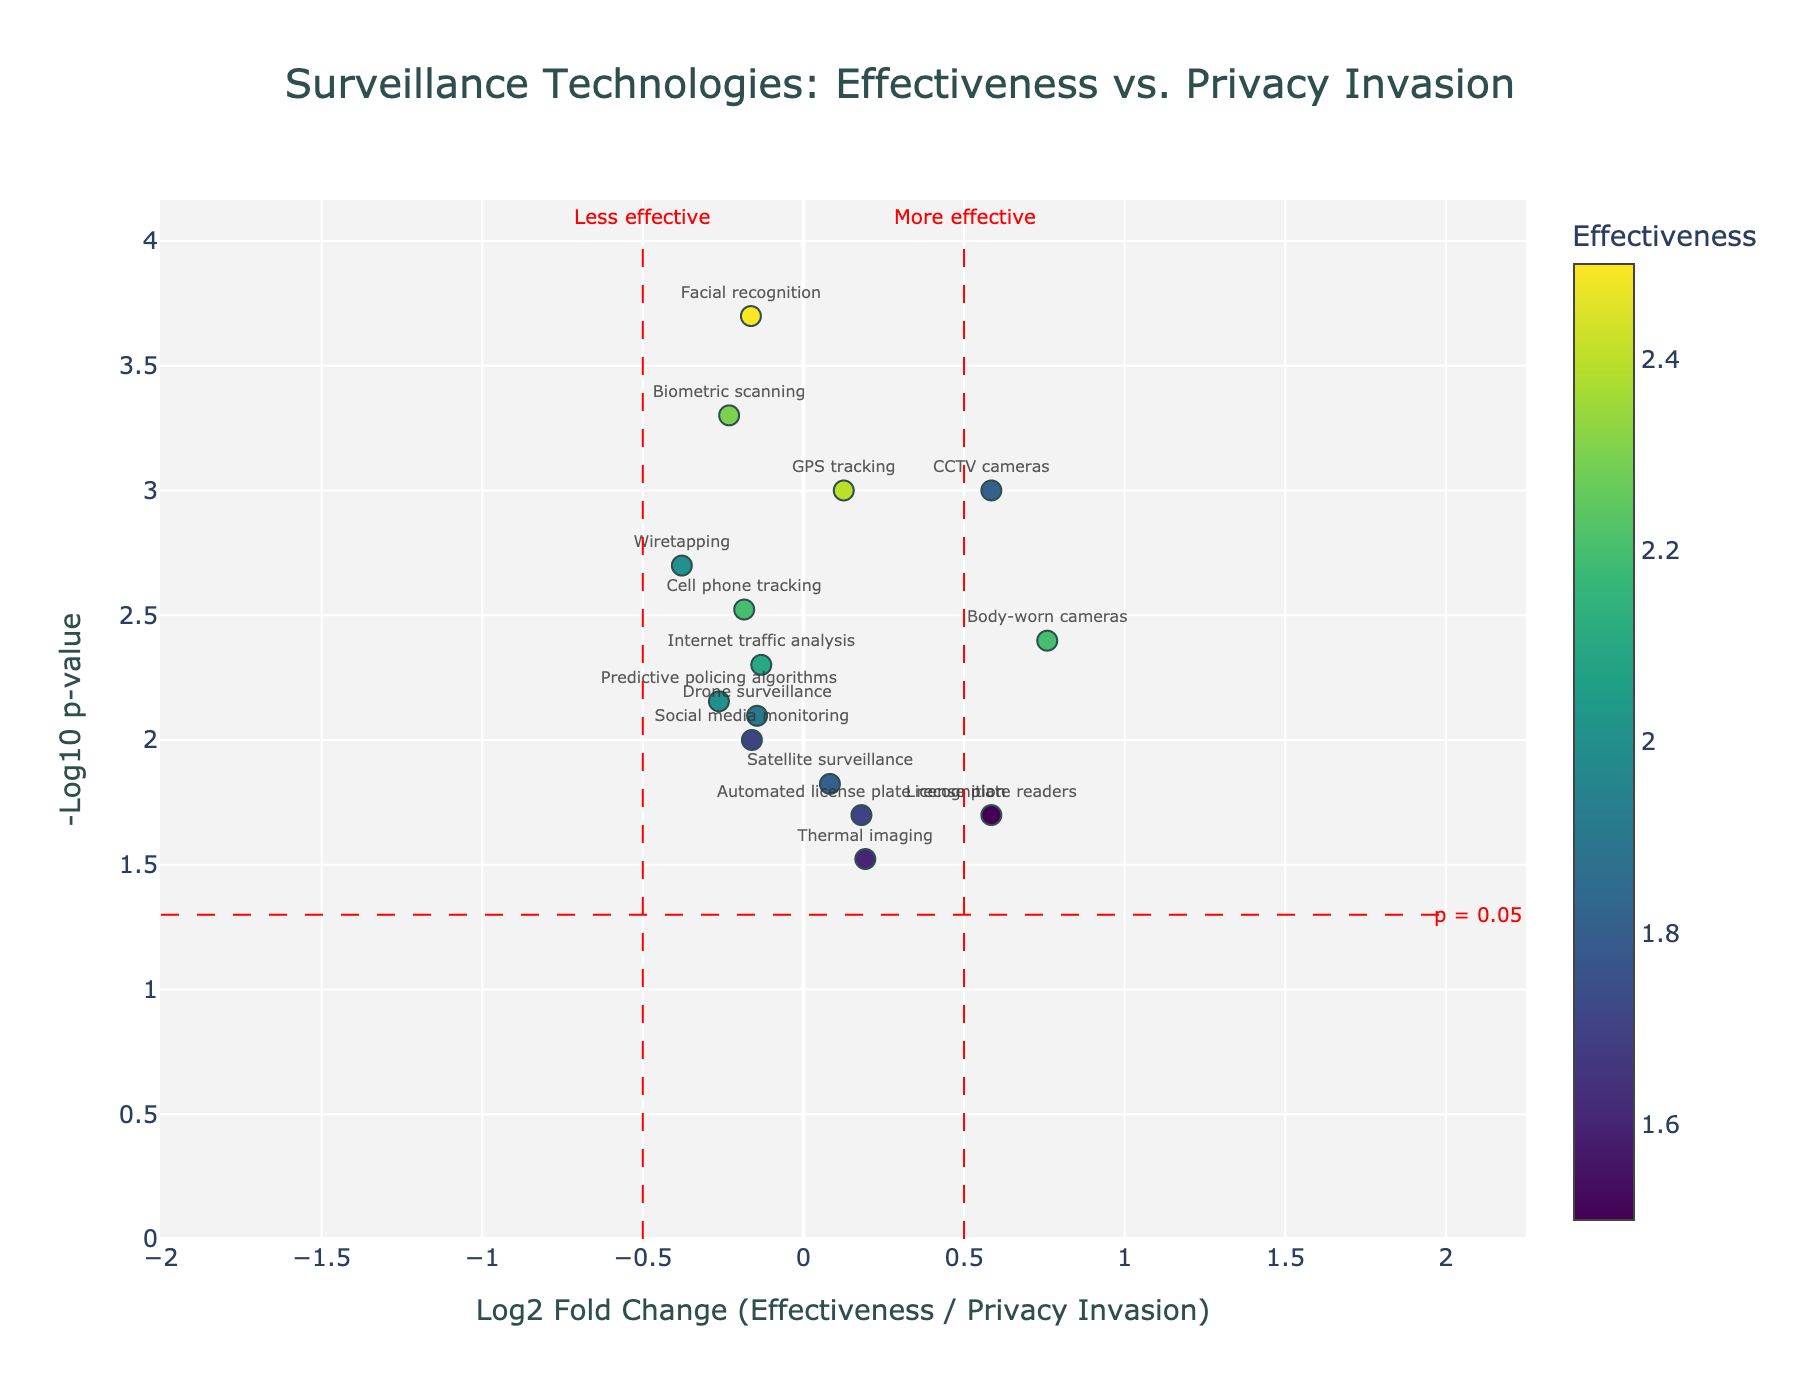What is the title of the plot? The title of the plot is located at the top center of the figure. It provides a summary of the chart's content and reads, "Surveillance Technologies: Effectiveness vs. Privacy Invasion."
Answer: Surveillance Technologies: Effectiveness vs. Privacy Invasion How many total surveillance technologies are represented in the plot? To determine the number of technologies represented, count the data points on the plot. There are 15 surveillance technologies listed in the data, which are all represented by markers in the plot.
Answer: 15 Which surveillance technology has the highest effectiveness? The surveillance technology with the highest effectiveness can be identified by looking for the marker with the highest text value on the 'Effectiveness' color scale. Facial recognition has the highest effectiveness value of 2.5.
Answer: Facial recognition Which technology shows the best balance between effectiveness and privacy invasion? To find the best balance, look for the marker closest to the horizontal blue line at Log2 Fold Change = 0. This represents equal effectiveness and privacy invasion. CCTV cameras (Log2 Fold Change ≈ 0.58) is the closest to this line.
Answer: CCTV cameras Which technology has the most significant p-value, and what does this indicate? To find the most significant p-value, look for the highest value on the y-axis (-Log10 p-value). Facial recognition has the highest -Log10 p-value (greater than 3), indicating it has the most significant p-value (smallest p-value).
Answer: Facial recognition Which technologies are classified as less effective based on the plot reference lines? By looking at the plot, technologies to the left of the vertical red dashed line labeled "Less effective" are considered less effective. These include License plate readers, Social media monitoring, Thermal imaging, and Satellite surveillance.
Answer: License plate readers, Social media monitoring, Thermal imaging, Satellite surveillance Which technology shows a significant balance towards privacy invasion compared to effectiveness? Look for the marker farthest to the left of the vertical dashed line at Log2 Fold Change = -0.5. Facial recognition, with a log2 fold change around -0.32 and high privacy invasion, fits this description.
Answer: Facial recognition Which surveillance technologies have a p-value threshold of less than 0.05? Technologies with a -Log10 p-value above 1.3 line surpass the significant p-value threshold (0.05). These include most listed technologies, but specifically not License plate readers, Thermal imaging, and Social media monitoring.
Answer: Most technologies excluding License plate readers, Thermal imaging, Social media monitoring Which technology has nearly equal values for effectiveness and privacy invasion, rendering a Log2 Fold Change close to zero? The Log2 Fold Change zero line indicates nearly equal values for effectiveness and privacy invasion. The technology closest to this line without significant deviation is CCTV cameras.
Answer: CCTV cameras How does wiretapping compare to GPS tracking in terms of fold-change and significance? Compare their positions on the plot. Wiretapping has a slightly lower log2 fold change but is similarly positioned in effectiveness and privacy invasion significance as GPS tracking. Both share similar Log2 Fold Change and -Log10 p-value.
Answer: Wiretapping slightly lower log2 fold change, similarly significant as GPS tracking 